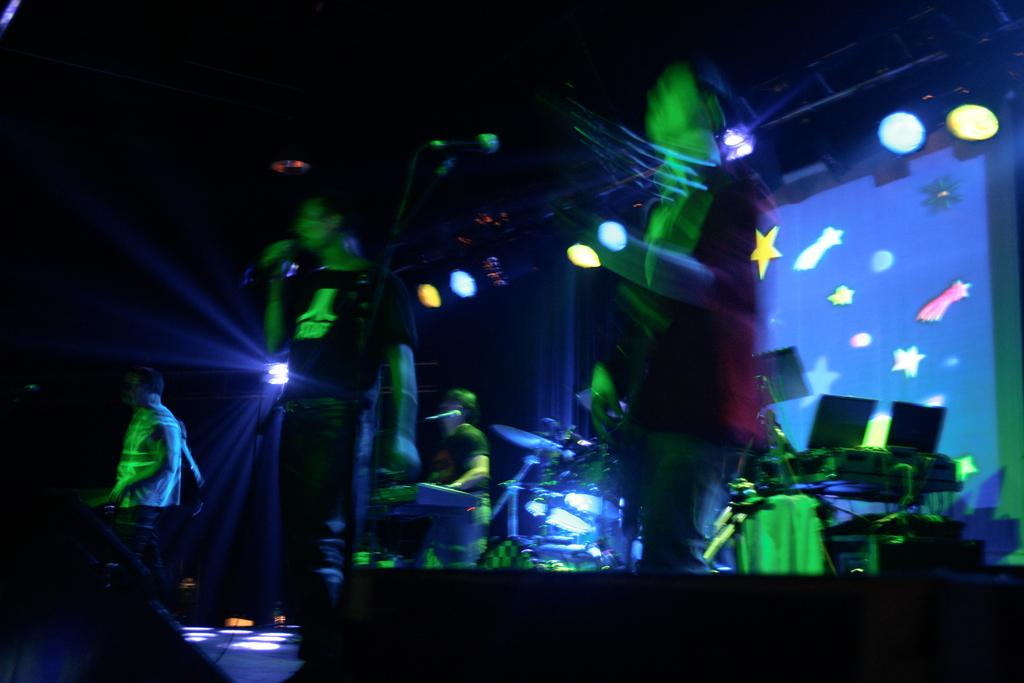What is happening on the stage in the image? There are persons on the stage, some of whom are singing and others playing musical instruments. What can be seen in the background of the stage? There are colored lights visible in the image. What type of pancake is being rewarded on stage in the image? There is no pancake present in the image, nor is anyone being rewarded. 